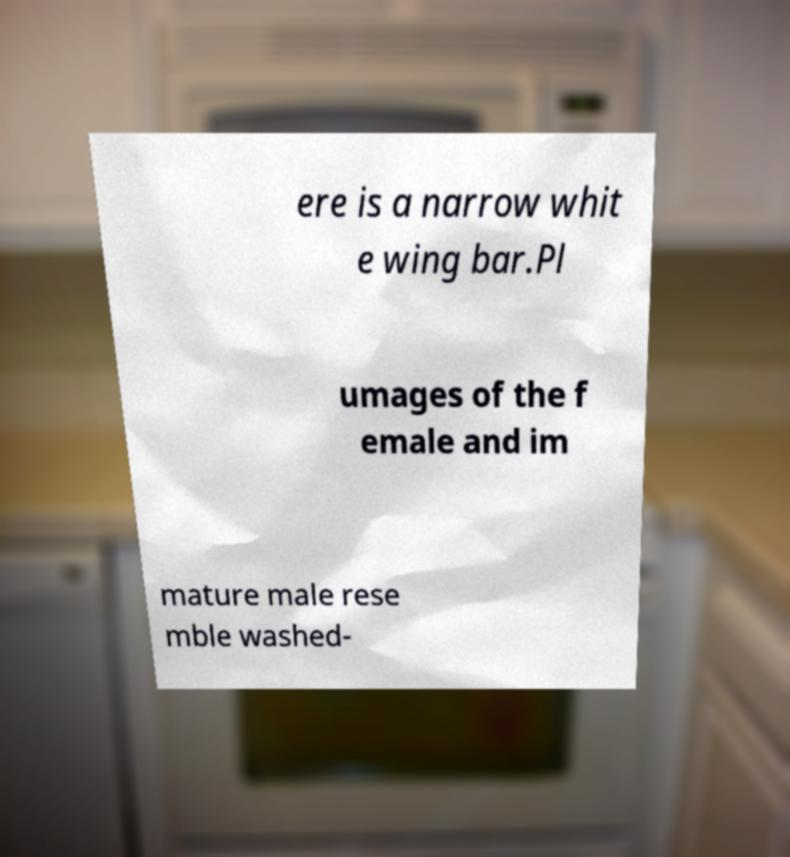Please read and relay the text visible in this image. What does it say? ere is a narrow whit e wing bar.Pl umages of the f emale and im mature male rese mble washed- 